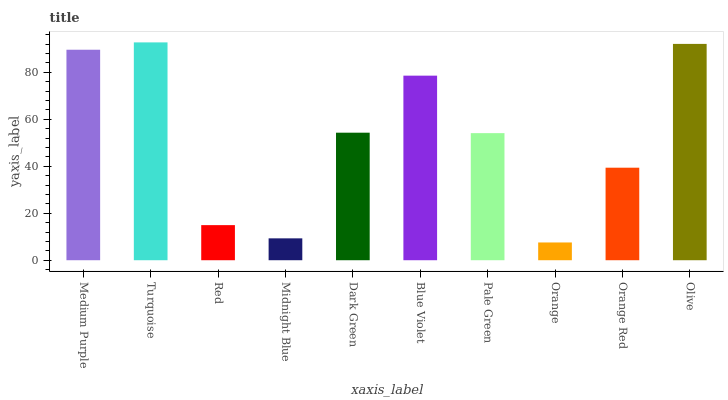Is Orange the minimum?
Answer yes or no. Yes. Is Turquoise the maximum?
Answer yes or no. Yes. Is Red the minimum?
Answer yes or no. No. Is Red the maximum?
Answer yes or no. No. Is Turquoise greater than Red?
Answer yes or no. Yes. Is Red less than Turquoise?
Answer yes or no. Yes. Is Red greater than Turquoise?
Answer yes or no. No. Is Turquoise less than Red?
Answer yes or no. No. Is Dark Green the high median?
Answer yes or no. Yes. Is Pale Green the low median?
Answer yes or no. Yes. Is Midnight Blue the high median?
Answer yes or no. No. Is Orange Red the low median?
Answer yes or no. No. 